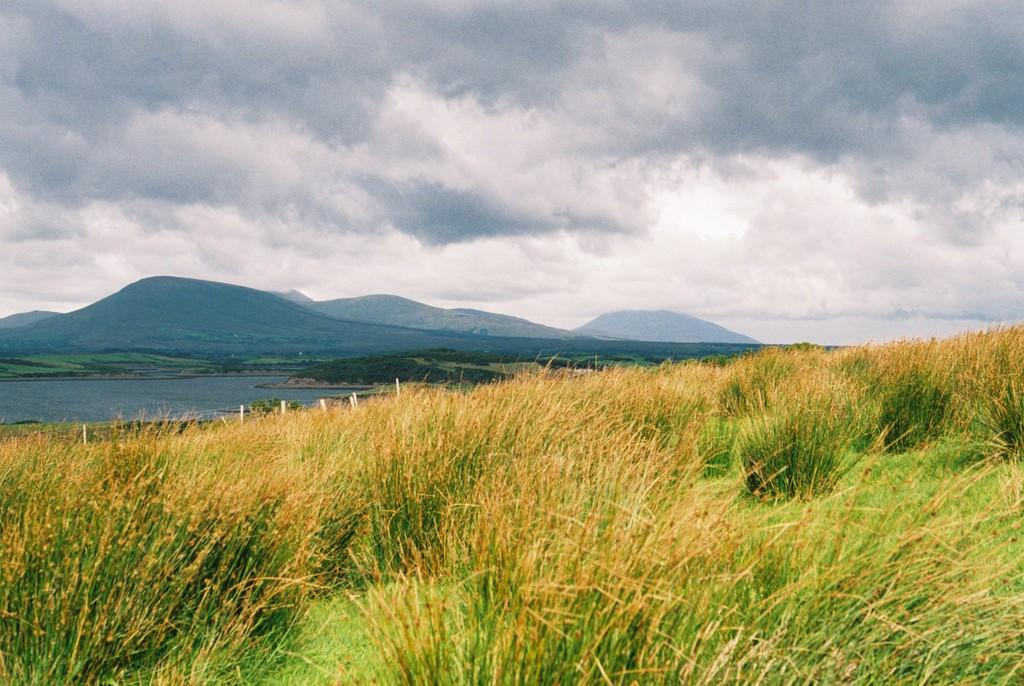What type of landscape is depicted in the image? There is a grassland in the image. Where is the water located in the image? The water is on the left side of the image. What is located beside the water? There is land with trees beside the water. What can be seen in the background of the image? There are hills visible in the background of the image. What is visible at the top of the image? The sky is visible at the top of the image. What can be observed in the sky? There are clouds in the sky. What is the weight of the loaf of bread in the image? There is no loaf of bread present in the image. On which side of the image is the weight of the loaf of bread mentioned? The image does not mention any loaf of bread or its weight, so there is no side to reference. 